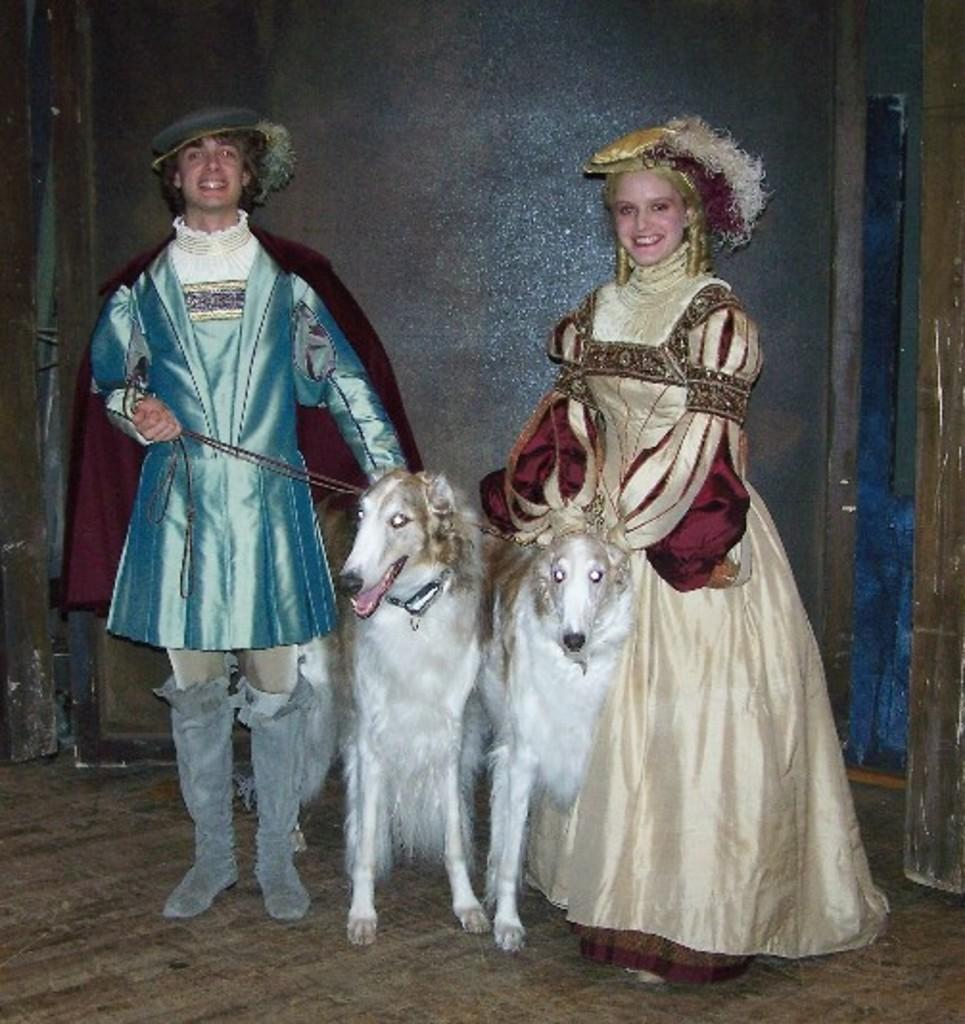What is the appearance of the man in the image? There is a man in the image, and he is wearing a costume. What is the appearance of the woman in the image? There is a woman in the image, and she is wearing a costume. Can you describe the animals present in the image? There are two animals in the image. What type of sugar is being used to feed the animals on the island in the image? There is no island, sugar, or animals present in the image. What type of beef is being served at the event in the image? There is no event or beef present in the image. 